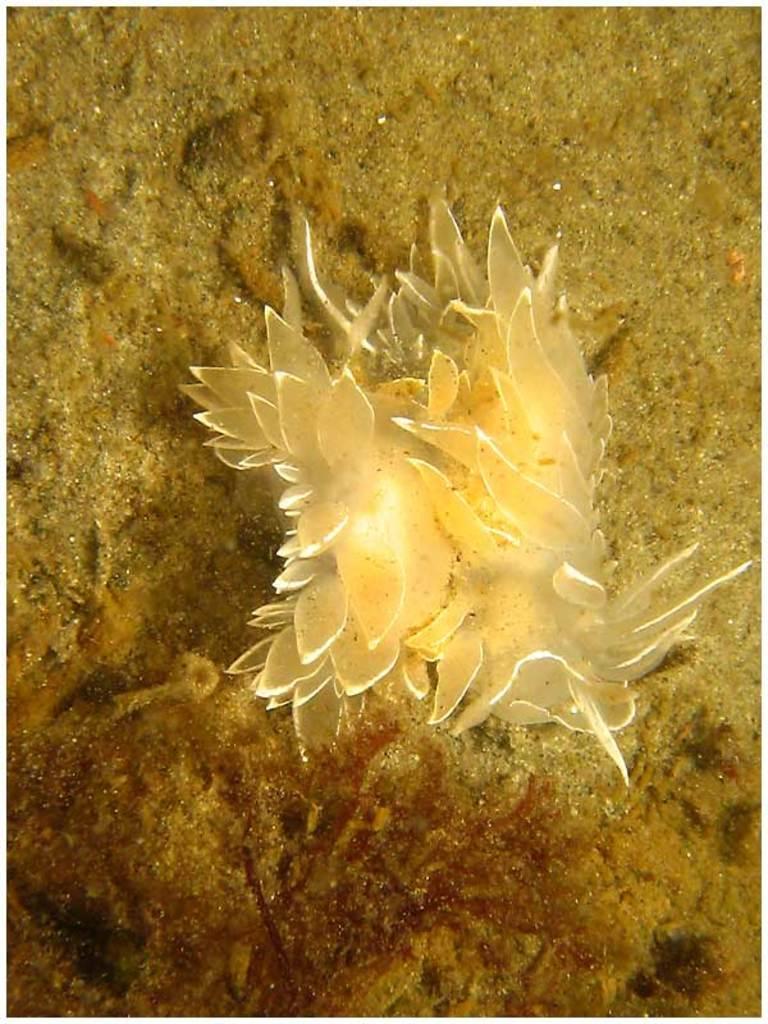How would you summarize this image in a sentence or two? In the image we can see water plants and sand. 